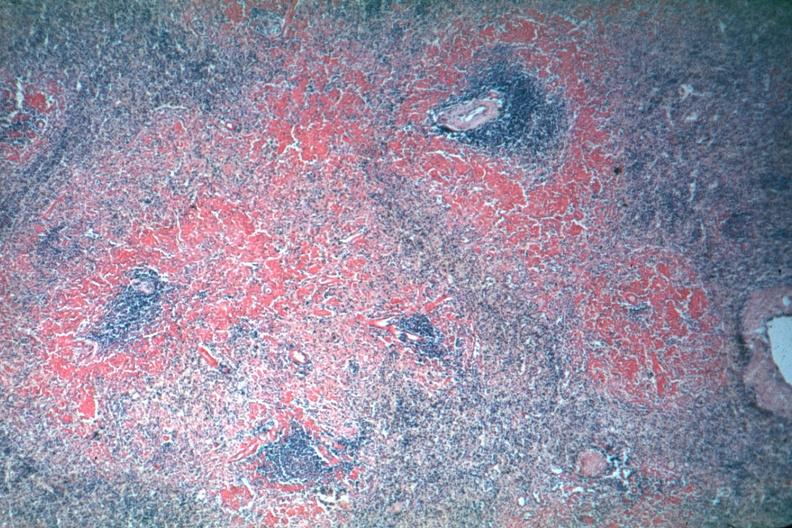what is present?
Answer the question using a single word or phrase. Hematologic 